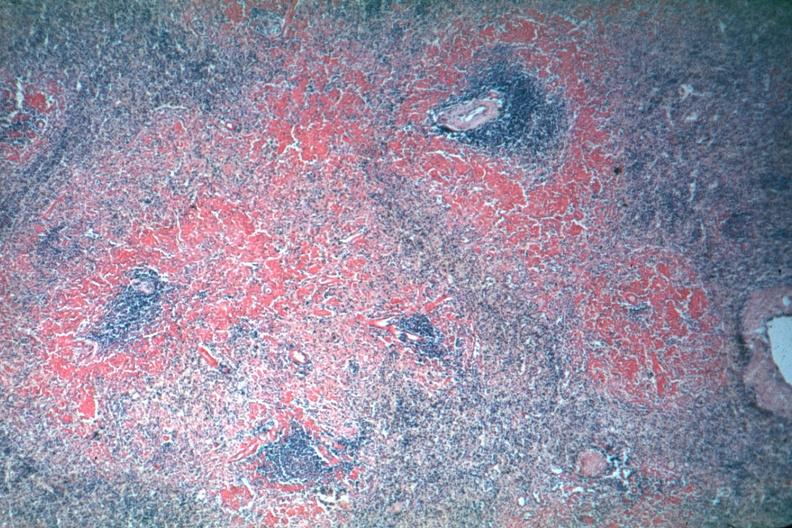what is present?
Answer the question using a single word or phrase. Hematologic 